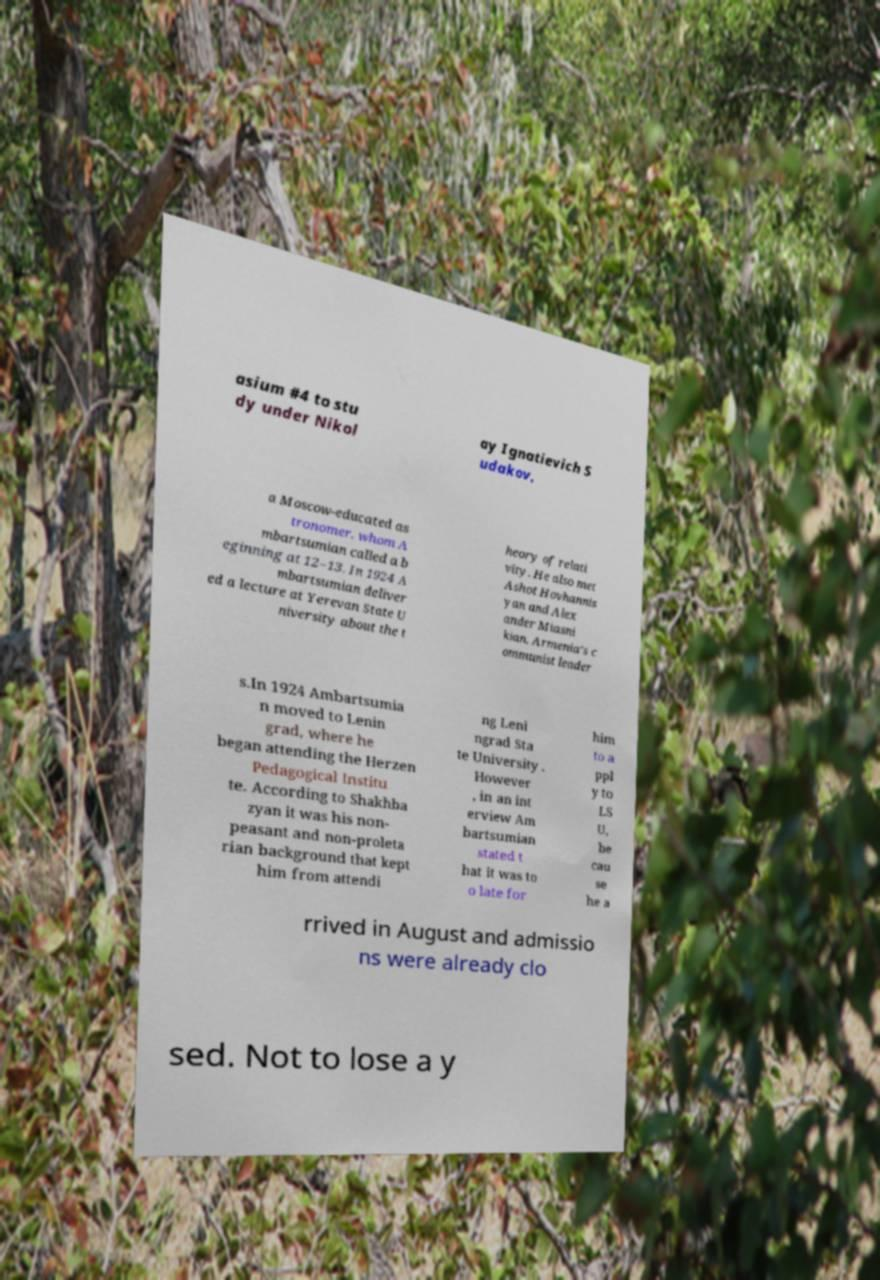What messages or text are displayed in this image? I need them in a readable, typed format. asium #4 to stu dy under Nikol ay Ignatievich S udakov, a Moscow-educated as tronomer, whom A mbartsumian called a b eginning at 12–13. In 1924 A mbartsumian deliver ed a lecture at Yerevan State U niversity about the t heory of relati vity. He also met Ashot Hovhannis yan and Alex ander Miasni kian, Armenia's c ommunist leader s.In 1924 Ambartsumia n moved to Lenin grad, where he began attending the Herzen Pedagogical Institu te. According to Shakhba zyan it was his non- peasant and non-proleta rian background that kept him from attendi ng Leni ngrad Sta te University . However , in an int erview Am bartsumian stated t hat it was to o late for him to a ppl y to LS U, be cau se he a rrived in August and admissio ns were already clo sed. Not to lose a y 